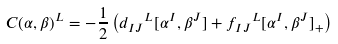Convert formula to latex. <formula><loc_0><loc_0><loc_500><loc_500>C ( \alpha , \beta ) ^ { L } = - \frac { 1 } { 2 } \left ( { d _ { I J } } ^ { L } [ \alpha ^ { I } , \beta ^ { J } ] + { f _ { I J } } ^ { L } [ \alpha ^ { I } , \beta ^ { J } ] _ { + } \right )</formula> 